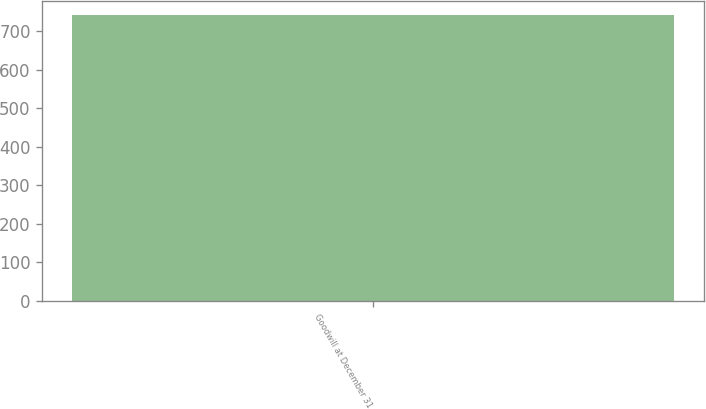Convert chart to OTSL. <chart><loc_0><loc_0><loc_500><loc_500><bar_chart><fcel>Goodwill at December 31<nl><fcel>740.2<nl></chart> 